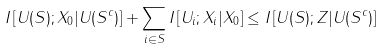Convert formula to latex. <formula><loc_0><loc_0><loc_500><loc_500>I \left [ U ( S ) ; X _ { 0 } | U ( S ^ { c } ) \right ] + \sum _ { i \in S } I \left [ U _ { i } ; X _ { i } | X _ { 0 } \right ] \leq I \left [ U ( S ) ; Z | U ( S ^ { c } ) \right ]</formula> 